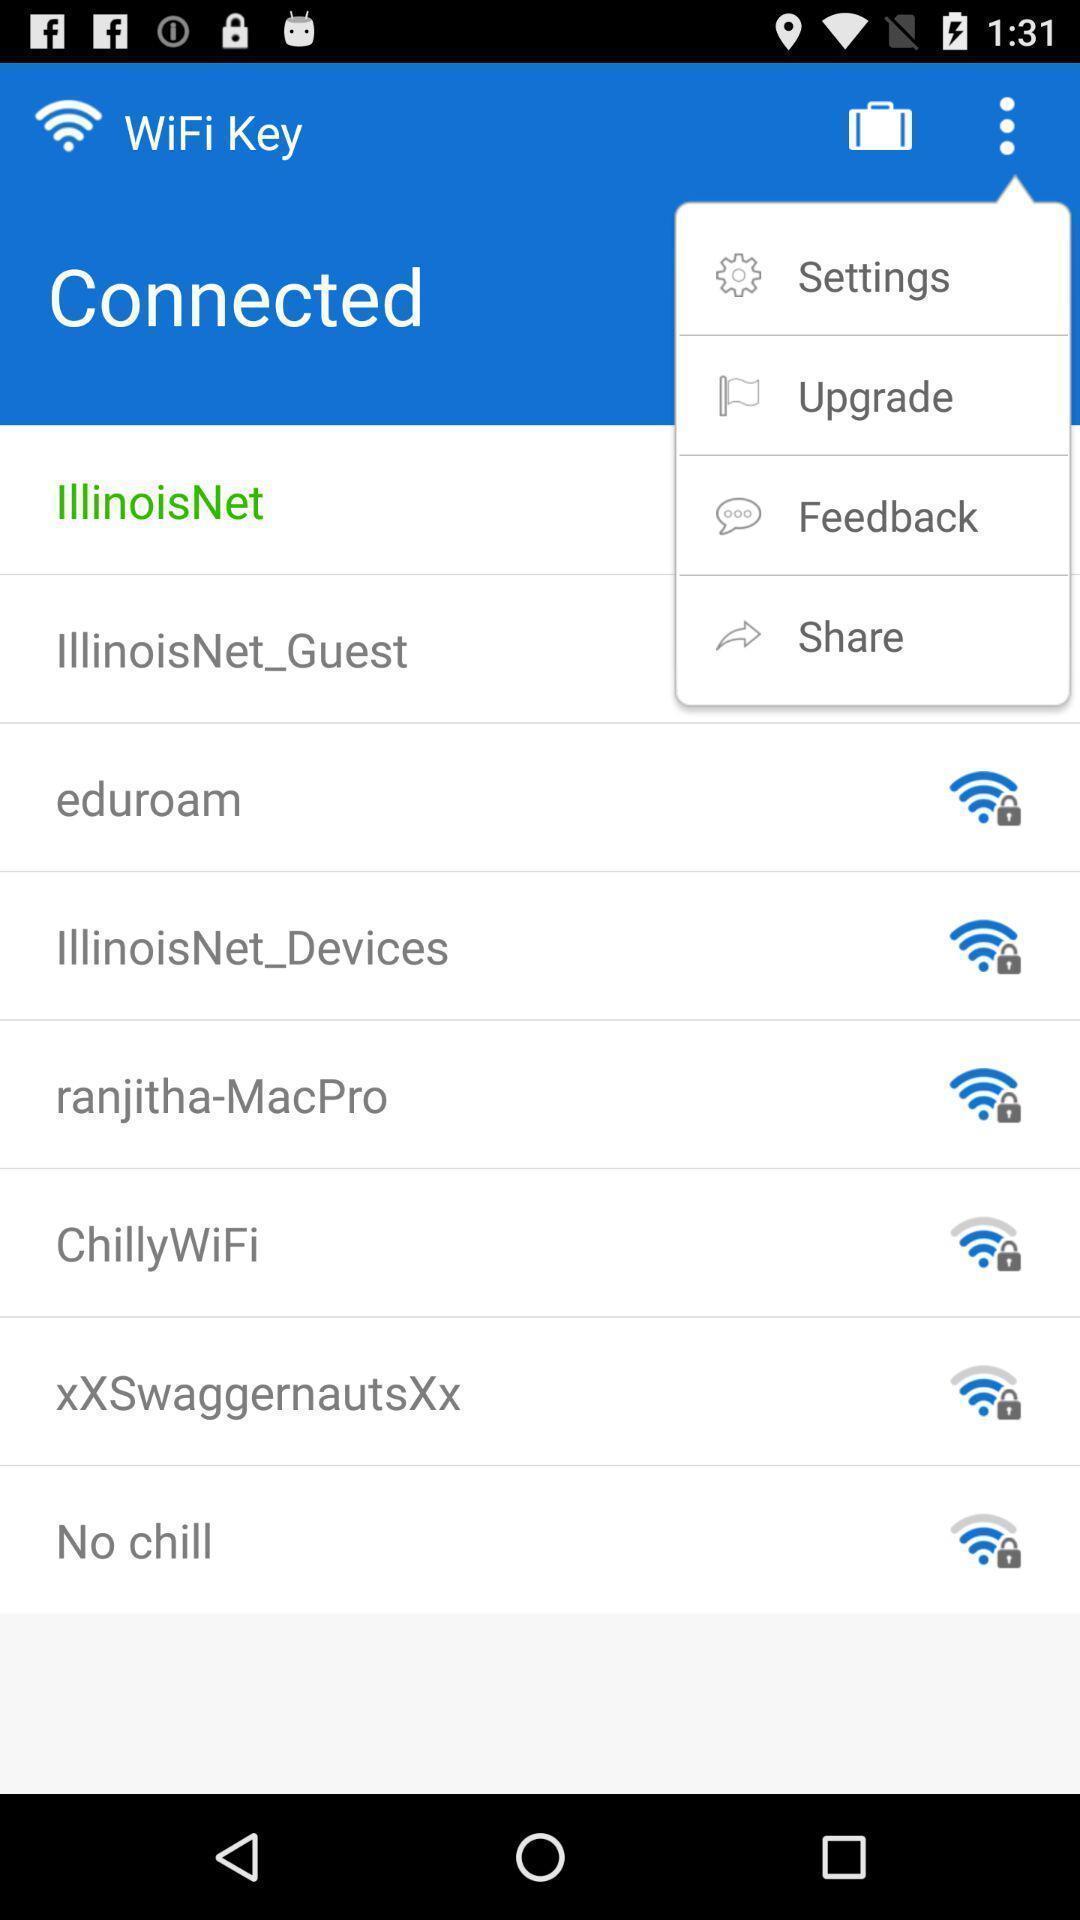Summarize the main components in this picture. Screen displaying the multiple options. 